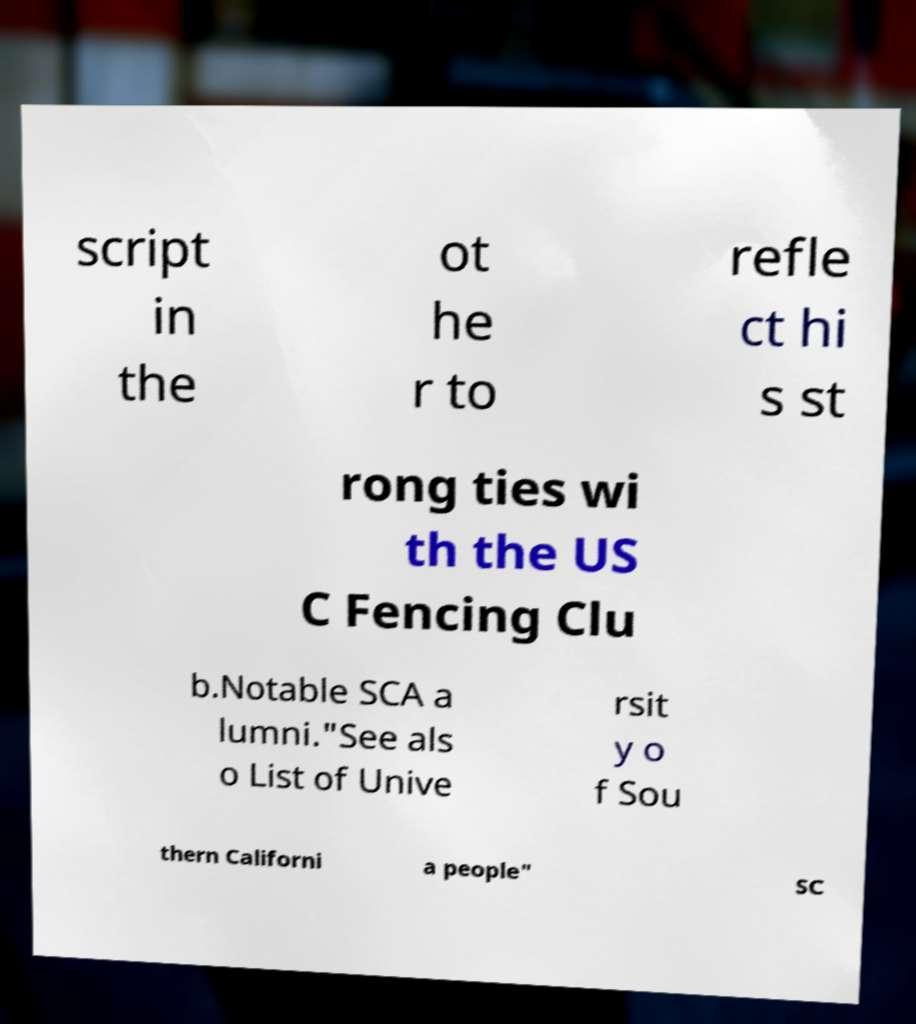I need the written content from this picture converted into text. Can you do that? script in the ot he r to refle ct hi s st rong ties wi th the US C Fencing Clu b.Notable SCA a lumni."See als o List of Unive rsit y o f Sou thern Californi a people" SC 